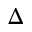<formula> <loc_0><loc_0><loc_500><loc_500>\Delta</formula> 